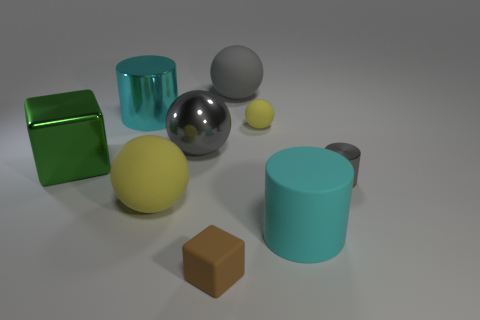What size is the thing that is the same color as the matte cylinder?
Ensure brevity in your answer.  Large. There is a large matte cylinder; how many large gray spheres are on the right side of it?
Give a very brief answer. 0. There is a cube that is in front of the object on the right side of the big cyan object in front of the big green block; what size is it?
Offer a terse response. Small. There is a large cyan cylinder in front of the block behind the big cyan matte cylinder; are there any tiny yellow rubber objects in front of it?
Offer a very short reply. No. Is the number of cyan metal things greater than the number of gray spheres?
Provide a succinct answer. No. What color is the cylinder behind the small shiny cylinder?
Offer a very short reply. Cyan. Are there more brown cubes that are behind the large green metal thing than tiny cubes?
Ensure brevity in your answer.  No. Does the small sphere have the same material as the gray cylinder?
Provide a short and direct response. No. How many other things are the same shape as the large yellow object?
Offer a terse response. 3. Is there any other thing that has the same material as the gray cylinder?
Your response must be concise. Yes. 